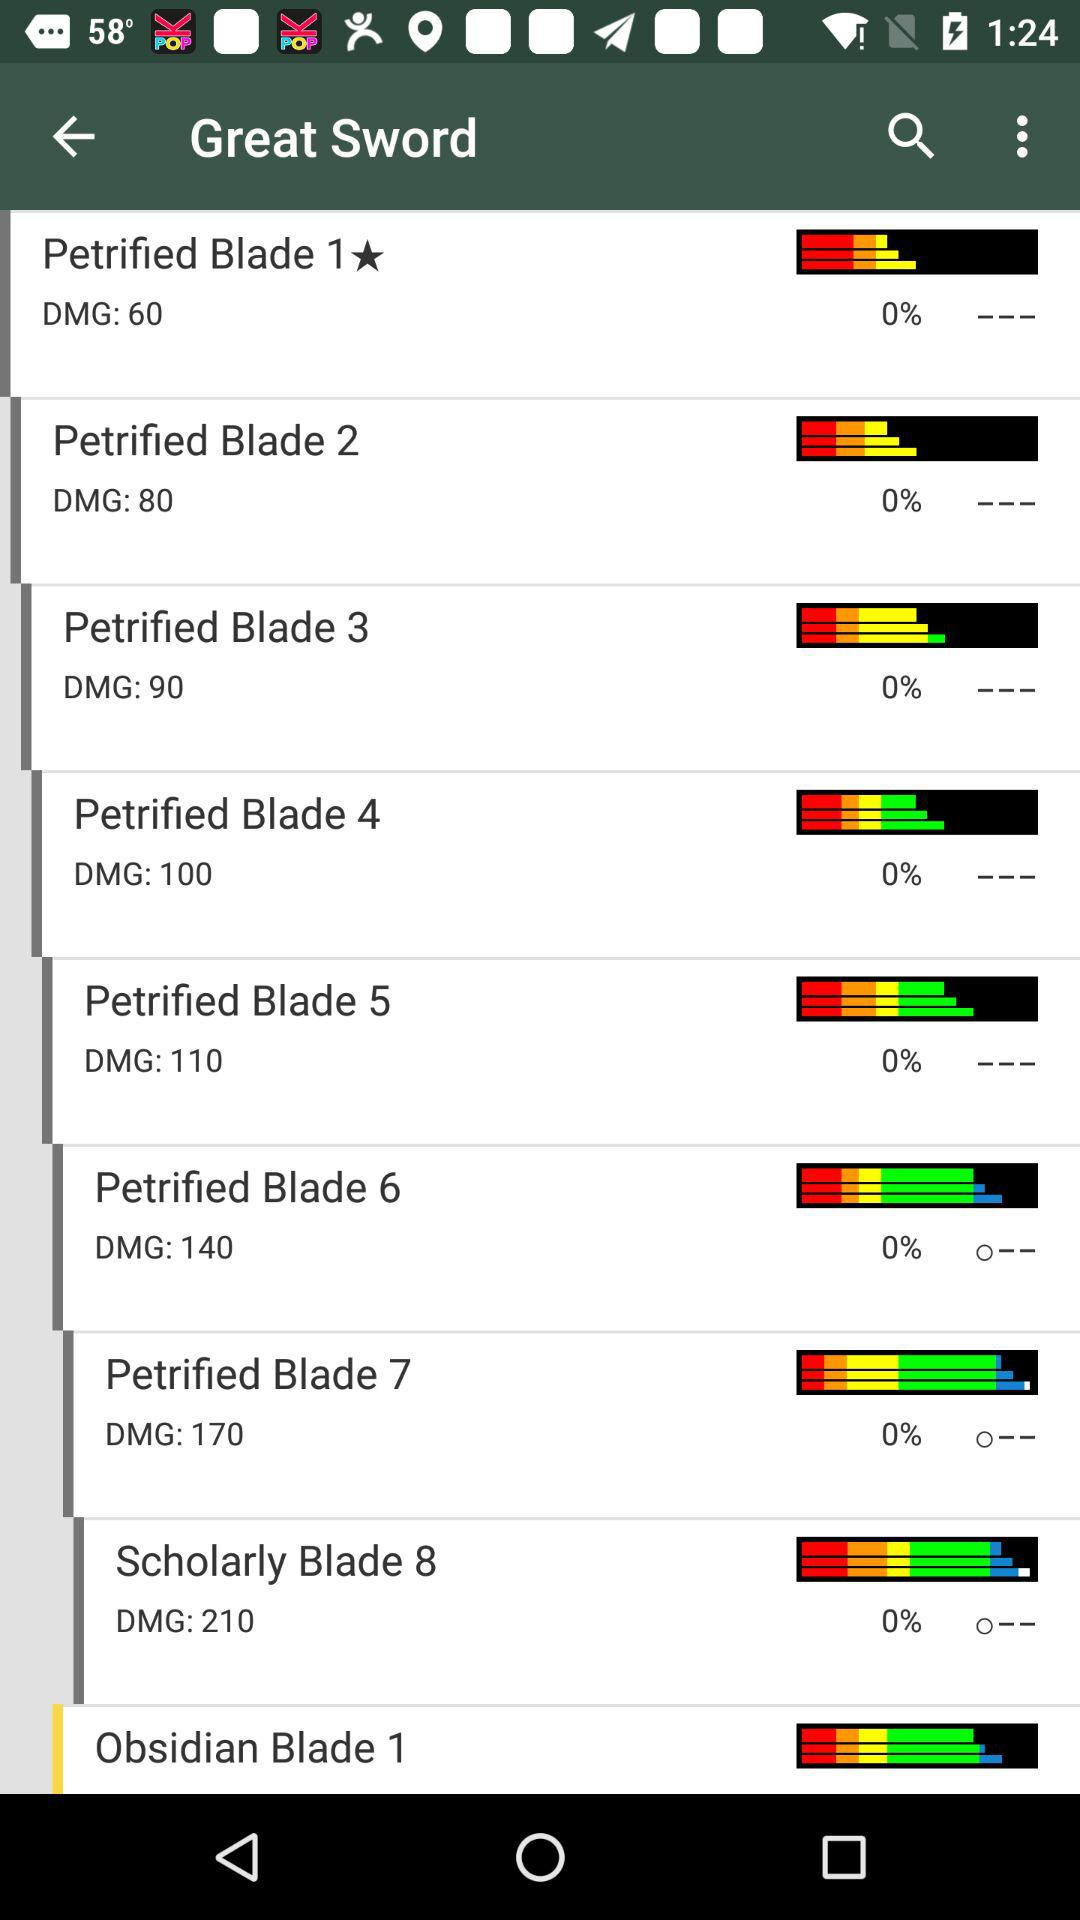What is the application name? The application name is "Great Sword". 